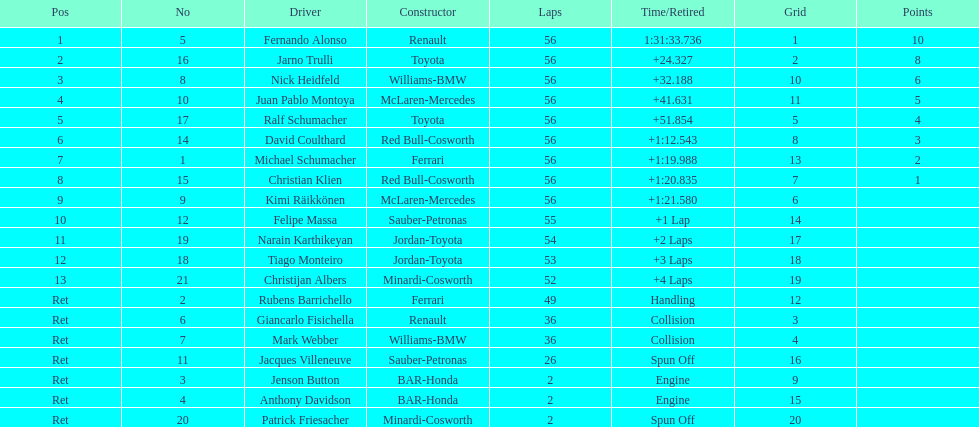How many drivers completed the race early because of engine troubles? 2. 